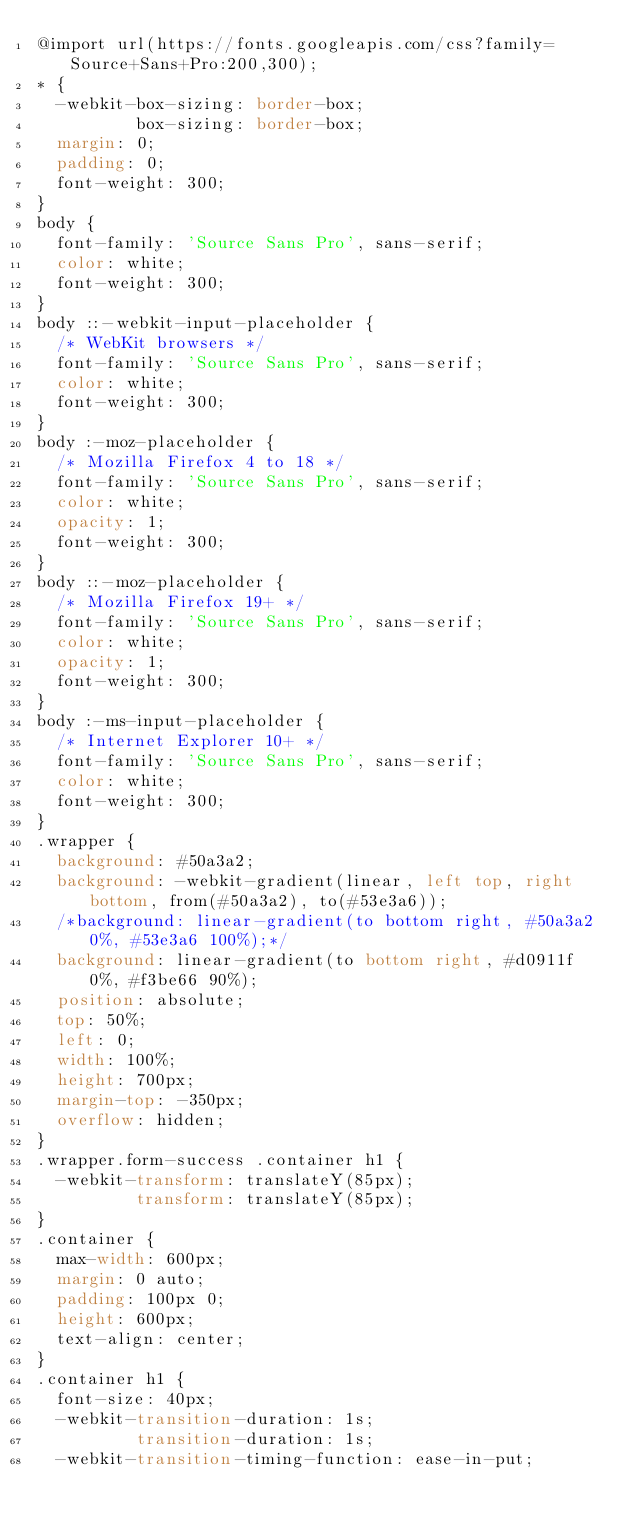Convert code to text. <code><loc_0><loc_0><loc_500><loc_500><_CSS_>@import url(https://fonts.googleapis.com/css?family=Source+Sans+Pro:200,300);
* {
  -webkit-box-sizing: border-box;
          box-sizing: border-box;
  margin: 0;
  padding: 0;
  font-weight: 300;
}
body {
  font-family: 'Source Sans Pro', sans-serif;
  color: white;
  font-weight: 300;
}
body ::-webkit-input-placeholder {
  /* WebKit browsers */
  font-family: 'Source Sans Pro', sans-serif;
  color: white;
  font-weight: 300;
}
body :-moz-placeholder {
  /* Mozilla Firefox 4 to 18 */
  font-family: 'Source Sans Pro', sans-serif;
  color: white;
  opacity: 1;
  font-weight: 300;
}
body ::-moz-placeholder {
  /* Mozilla Firefox 19+ */
  font-family: 'Source Sans Pro', sans-serif;
  color: white;
  opacity: 1;
  font-weight: 300;
}
body :-ms-input-placeholder {
  /* Internet Explorer 10+ */
  font-family: 'Source Sans Pro', sans-serif;
  color: white;
  font-weight: 300;
}
.wrapper {
  background: #50a3a2;
  background: -webkit-gradient(linear, left top, right bottom, from(#50a3a2), to(#53e3a6));
  /*background: linear-gradient(to bottom right, #50a3a2 0%, #53e3a6 100%);*/
  background: linear-gradient(to bottom right, #d0911f 0%, #f3be66 90%);
  position: absolute;
  top: 50%;
  left: 0;
  width: 100%;
  height: 700px;
  margin-top: -350px;
  overflow: hidden;
}
.wrapper.form-success .container h1 {
  -webkit-transform: translateY(85px);
          transform: translateY(85px);
}
.container {
  max-width: 600px;
  margin: 0 auto;
  padding: 100px 0;
  height: 600px;
  text-align: center;
}
.container h1 {
  font-size: 40px;
  -webkit-transition-duration: 1s;
          transition-duration: 1s;
  -webkit-transition-timing-function: ease-in-put;</code> 